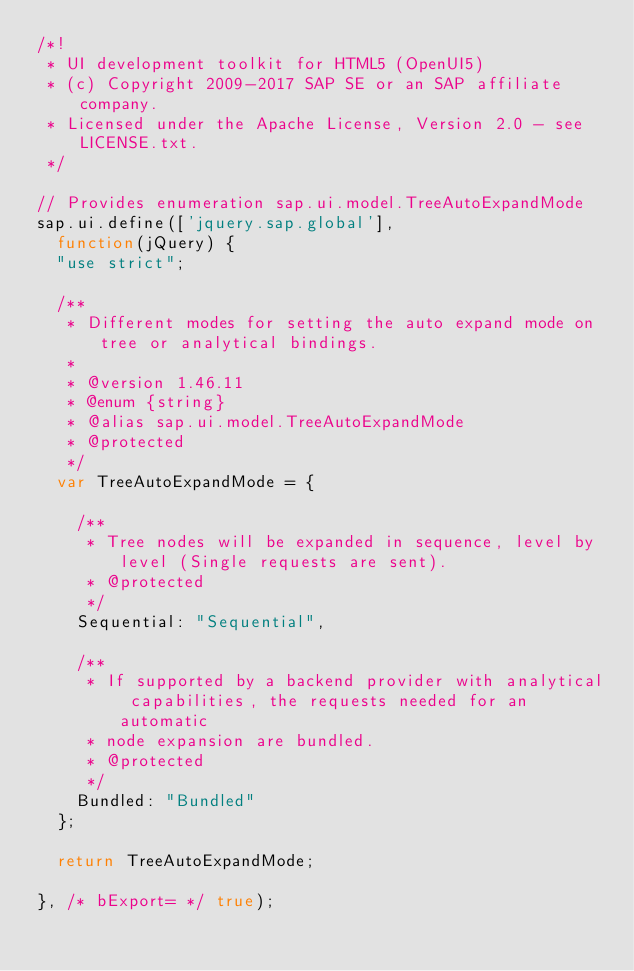Convert code to text. <code><loc_0><loc_0><loc_500><loc_500><_JavaScript_>/*!
 * UI development toolkit for HTML5 (OpenUI5)
 * (c) Copyright 2009-2017 SAP SE or an SAP affiliate company.
 * Licensed under the Apache License, Version 2.0 - see LICENSE.txt.
 */

// Provides enumeration sap.ui.model.TreeAutoExpandMode
sap.ui.define(['jquery.sap.global'],
	function(jQuery) {
	"use strict";

	/**
	 * Different modes for setting the auto expand mode on tree or analytical bindings.
	 *
	 * @version 1.46.11
	 * @enum {string}
	 * @alias sap.ui.model.TreeAutoExpandMode
	 * @protected
	 */
	var TreeAutoExpandMode = {

		/**
		 * Tree nodes will be expanded in sequence, level by level (Single requests are sent).
		 * @protected
		 */
		Sequential: "Sequential",

		/**
		 * If supported by a backend provider with analytical capabilities, the requests needed for an automatic
		 * node expansion are bundled.
		 * @protected
		 */
		Bundled: "Bundled"
	};

	return TreeAutoExpandMode;

}, /* bExport= */ true);</code> 